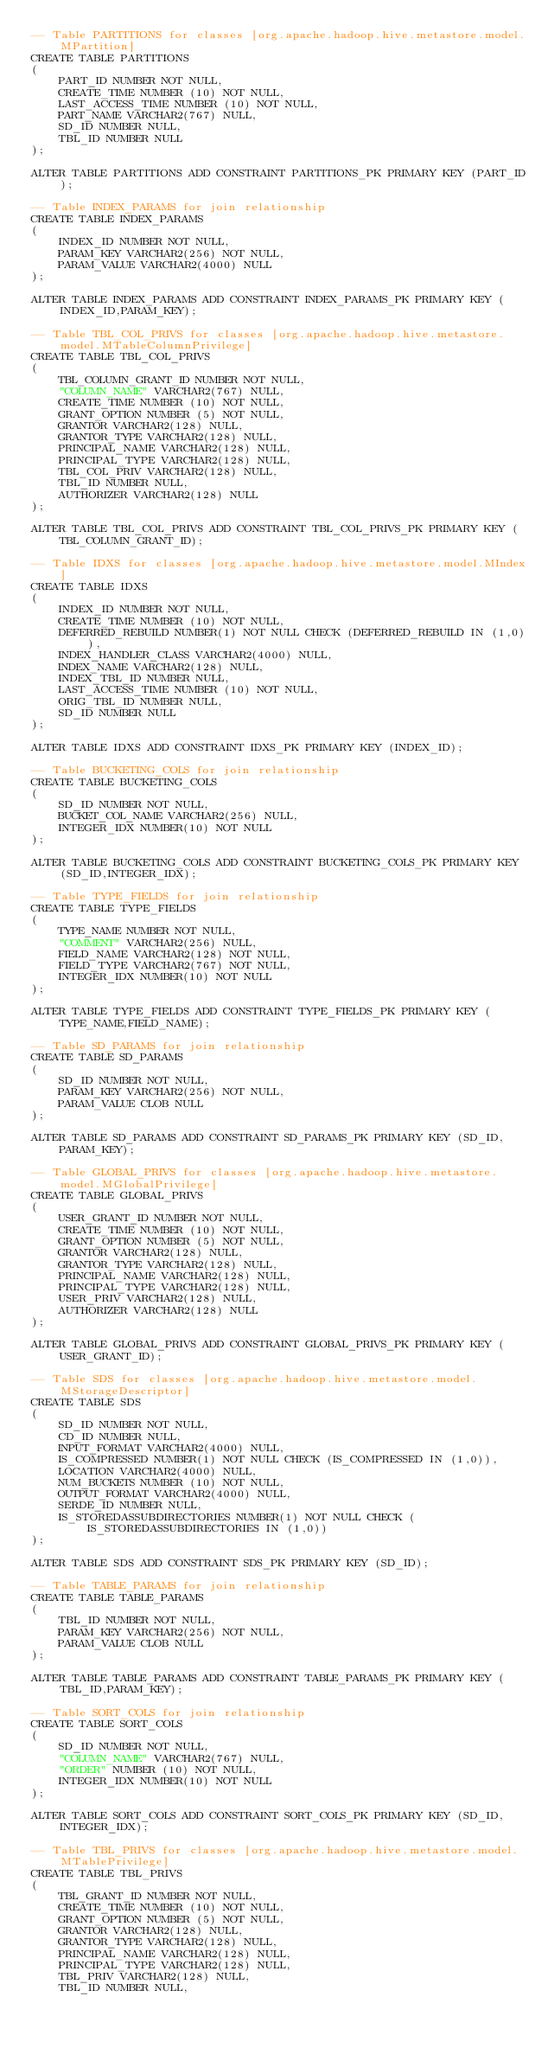<code> <loc_0><loc_0><loc_500><loc_500><_SQL_>-- Table PARTITIONS for classes [org.apache.hadoop.hive.metastore.model.MPartition]
CREATE TABLE PARTITIONS
(
    PART_ID NUMBER NOT NULL,
    CREATE_TIME NUMBER (10) NOT NULL,
    LAST_ACCESS_TIME NUMBER (10) NOT NULL,
    PART_NAME VARCHAR2(767) NULL,
    SD_ID NUMBER NULL,
    TBL_ID NUMBER NULL
);

ALTER TABLE PARTITIONS ADD CONSTRAINT PARTITIONS_PK PRIMARY KEY (PART_ID);

-- Table INDEX_PARAMS for join relationship
CREATE TABLE INDEX_PARAMS
(
    INDEX_ID NUMBER NOT NULL,
    PARAM_KEY VARCHAR2(256) NOT NULL,
    PARAM_VALUE VARCHAR2(4000) NULL
);

ALTER TABLE INDEX_PARAMS ADD CONSTRAINT INDEX_PARAMS_PK PRIMARY KEY (INDEX_ID,PARAM_KEY);

-- Table TBL_COL_PRIVS for classes [org.apache.hadoop.hive.metastore.model.MTableColumnPrivilege]
CREATE TABLE TBL_COL_PRIVS
(
    TBL_COLUMN_GRANT_ID NUMBER NOT NULL,
    "COLUMN_NAME" VARCHAR2(767) NULL,
    CREATE_TIME NUMBER (10) NOT NULL,
    GRANT_OPTION NUMBER (5) NOT NULL,
    GRANTOR VARCHAR2(128) NULL,
    GRANTOR_TYPE VARCHAR2(128) NULL,
    PRINCIPAL_NAME VARCHAR2(128) NULL,
    PRINCIPAL_TYPE VARCHAR2(128) NULL,
    TBL_COL_PRIV VARCHAR2(128) NULL,
    TBL_ID NUMBER NULL,
    AUTHORIZER VARCHAR2(128) NULL
);

ALTER TABLE TBL_COL_PRIVS ADD CONSTRAINT TBL_COL_PRIVS_PK PRIMARY KEY (TBL_COLUMN_GRANT_ID);

-- Table IDXS for classes [org.apache.hadoop.hive.metastore.model.MIndex]
CREATE TABLE IDXS
(
    INDEX_ID NUMBER NOT NULL,
    CREATE_TIME NUMBER (10) NOT NULL,
    DEFERRED_REBUILD NUMBER(1) NOT NULL CHECK (DEFERRED_REBUILD IN (1,0)),
    INDEX_HANDLER_CLASS VARCHAR2(4000) NULL,
    INDEX_NAME VARCHAR2(128) NULL,
    INDEX_TBL_ID NUMBER NULL,
    LAST_ACCESS_TIME NUMBER (10) NOT NULL,
    ORIG_TBL_ID NUMBER NULL,
    SD_ID NUMBER NULL
);

ALTER TABLE IDXS ADD CONSTRAINT IDXS_PK PRIMARY KEY (INDEX_ID);

-- Table BUCKETING_COLS for join relationship
CREATE TABLE BUCKETING_COLS
(
    SD_ID NUMBER NOT NULL,
    BUCKET_COL_NAME VARCHAR2(256) NULL,
    INTEGER_IDX NUMBER(10) NOT NULL
);

ALTER TABLE BUCKETING_COLS ADD CONSTRAINT BUCKETING_COLS_PK PRIMARY KEY (SD_ID,INTEGER_IDX);

-- Table TYPE_FIELDS for join relationship
CREATE TABLE TYPE_FIELDS
(
    TYPE_NAME NUMBER NOT NULL,
    "COMMENT" VARCHAR2(256) NULL,
    FIELD_NAME VARCHAR2(128) NOT NULL,
    FIELD_TYPE VARCHAR2(767) NOT NULL,
    INTEGER_IDX NUMBER(10) NOT NULL
);

ALTER TABLE TYPE_FIELDS ADD CONSTRAINT TYPE_FIELDS_PK PRIMARY KEY (TYPE_NAME,FIELD_NAME);

-- Table SD_PARAMS for join relationship
CREATE TABLE SD_PARAMS
(
    SD_ID NUMBER NOT NULL,
    PARAM_KEY VARCHAR2(256) NOT NULL,
    PARAM_VALUE CLOB NULL
);

ALTER TABLE SD_PARAMS ADD CONSTRAINT SD_PARAMS_PK PRIMARY KEY (SD_ID,PARAM_KEY);

-- Table GLOBAL_PRIVS for classes [org.apache.hadoop.hive.metastore.model.MGlobalPrivilege]
CREATE TABLE GLOBAL_PRIVS
(
    USER_GRANT_ID NUMBER NOT NULL,
    CREATE_TIME NUMBER (10) NOT NULL,
    GRANT_OPTION NUMBER (5) NOT NULL,
    GRANTOR VARCHAR2(128) NULL,
    GRANTOR_TYPE VARCHAR2(128) NULL,
    PRINCIPAL_NAME VARCHAR2(128) NULL,
    PRINCIPAL_TYPE VARCHAR2(128) NULL,
    USER_PRIV VARCHAR2(128) NULL,
    AUTHORIZER VARCHAR2(128) NULL
);

ALTER TABLE GLOBAL_PRIVS ADD CONSTRAINT GLOBAL_PRIVS_PK PRIMARY KEY (USER_GRANT_ID);

-- Table SDS for classes [org.apache.hadoop.hive.metastore.model.MStorageDescriptor]
CREATE TABLE SDS
(
    SD_ID NUMBER NOT NULL,
    CD_ID NUMBER NULL,
    INPUT_FORMAT VARCHAR2(4000) NULL,
    IS_COMPRESSED NUMBER(1) NOT NULL CHECK (IS_COMPRESSED IN (1,0)),
    LOCATION VARCHAR2(4000) NULL,
    NUM_BUCKETS NUMBER (10) NOT NULL,
    OUTPUT_FORMAT VARCHAR2(4000) NULL,
    SERDE_ID NUMBER NULL,
    IS_STOREDASSUBDIRECTORIES NUMBER(1) NOT NULL CHECK (IS_STOREDASSUBDIRECTORIES IN (1,0))
);

ALTER TABLE SDS ADD CONSTRAINT SDS_PK PRIMARY KEY (SD_ID);

-- Table TABLE_PARAMS for join relationship
CREATE TABLE TABLE_PARAMS
(
    TBL_ID NUMBER NOT NULL,
    PARAM_KEY VARCHAR2(256) NOT NULL,
    PARAM_VALUE CLOB NULL
);

ALTER TABLE TABLE_PARAMS ADD CONSTRAINT TABLE_PARAMS_PK PRIMARY KEY (TBL_ID,PARAM_KEY);

-- Table SORT_COLS for join relationship
CREATE TABLE SORT_COLS
(
    SD_ID NUMBER NOT NULL,
    "COLUMN_NAME" VARCHAR2(767) NULL,
    "ORDER" NUMBER (10) NOT NULL,
    INTEGER_IDX NUMBER(10) NOT NULL
);

ALTER TABLE SORT_COLS ADD CONSTRAINT SORT_COLS_PK PRIMARY KEY (SD_ID,INTEGER_IDX);

-- Table TBL_PRIVS for classes [org.apache.hadoop.hive.metastore.model.MTablePrivilege]
CREATE TABLE TBL_PRIVS
(
    TBL_GRANT_ID NUMBER NOT NULL,
    CREATE_TIME NUMBER (10) NOT NULL,
    GRANT_OPTION NUMBER (5) NOT NULL,
    GRANTOR VARCHAR2(128) NULL,
    GRANTOR_TYPE VARCHAR2(128) NULL,
    PRINCIPAL_NAME VARCHAR2(128) NULL,
    PRINCIPAL_TYPE VARCHAR2(128) NULL,
    TBL_PRIV VARCHAR2(128) NULL,
    TBL_ID NUMBER NULL,</code> 